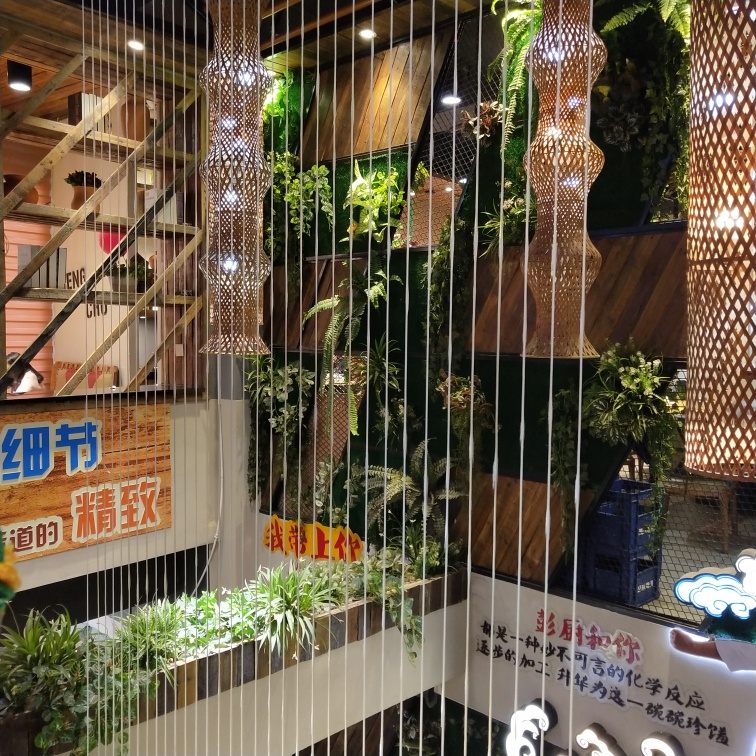Could you describe the style of decoration in this scene? The decoration style seems modern with an Asian influence, likely East Asian. The mix of warm wood tones, hanging lights that resemble lanterns, and natural greenery suggests a fusion of contemporary design with traditional elements. 